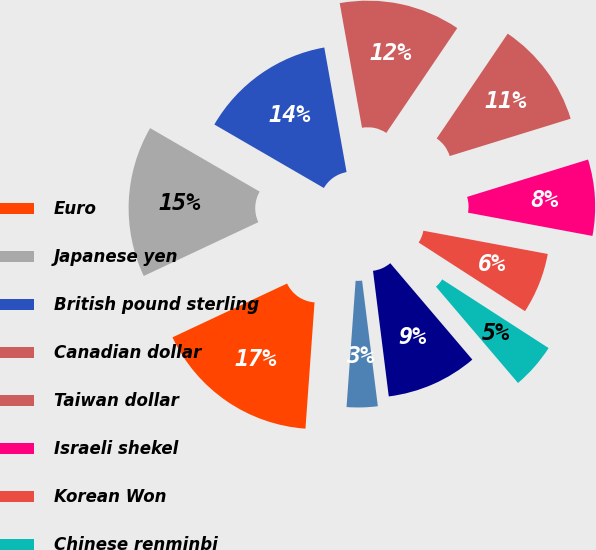Convert chart to OTSL. <chart><loc_0><loc_0><loc_500><loc_500><pie_chart><fcel>Euro<fcel>Japanese yen<fcel>British pound sterling<fcel>Canadian dollar<fcel>Taiwan dollar<fcel>Israeli shekel<fcel>Korean Won<fcel>Chinese renminbi<fcel>India Rupee<fcel>Singapore dollar<nl><fcel>16.87%<fcel>15.35%<fcel>13.82%<fcel>12.29%<fcel>10.76%<fcel>7.71%<fcel>6.18%<fcel>4.65%<fcel>9.24%<fcel>3.13%<nl></chart> 